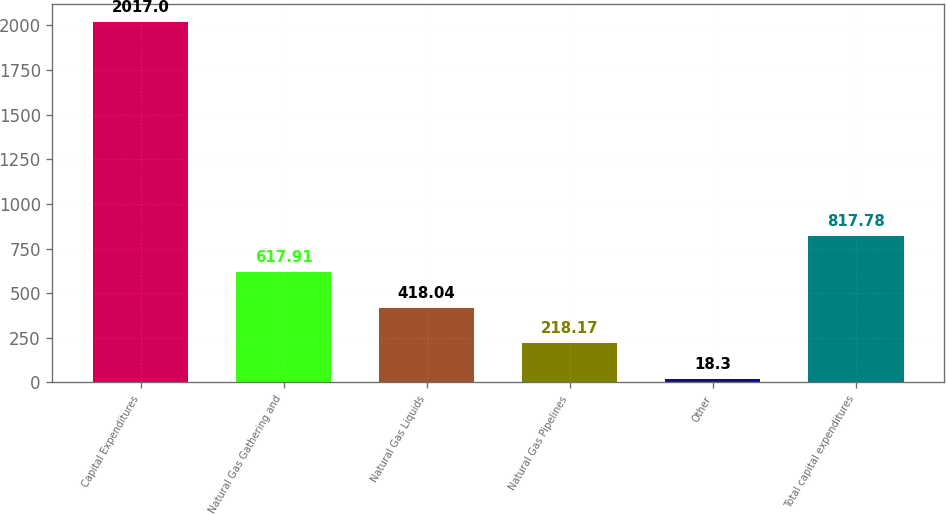Convert chart to OTSL. <chart><loc_0><loc_0><loc_500><loc_500><bar_chart><fcel>Capital Expenditures<fcel>Natural Gas Gathering and<fcel>Natural Gas Liquids<fcel>Natural Gas Pipelines<fcel>Other<fcel>Total capital expenditures<nl><fcel>2017<fcel>617.91<fcel>418.04<fcel>218.17<fcel>18.3<fcel>817.78<nl></chart> 